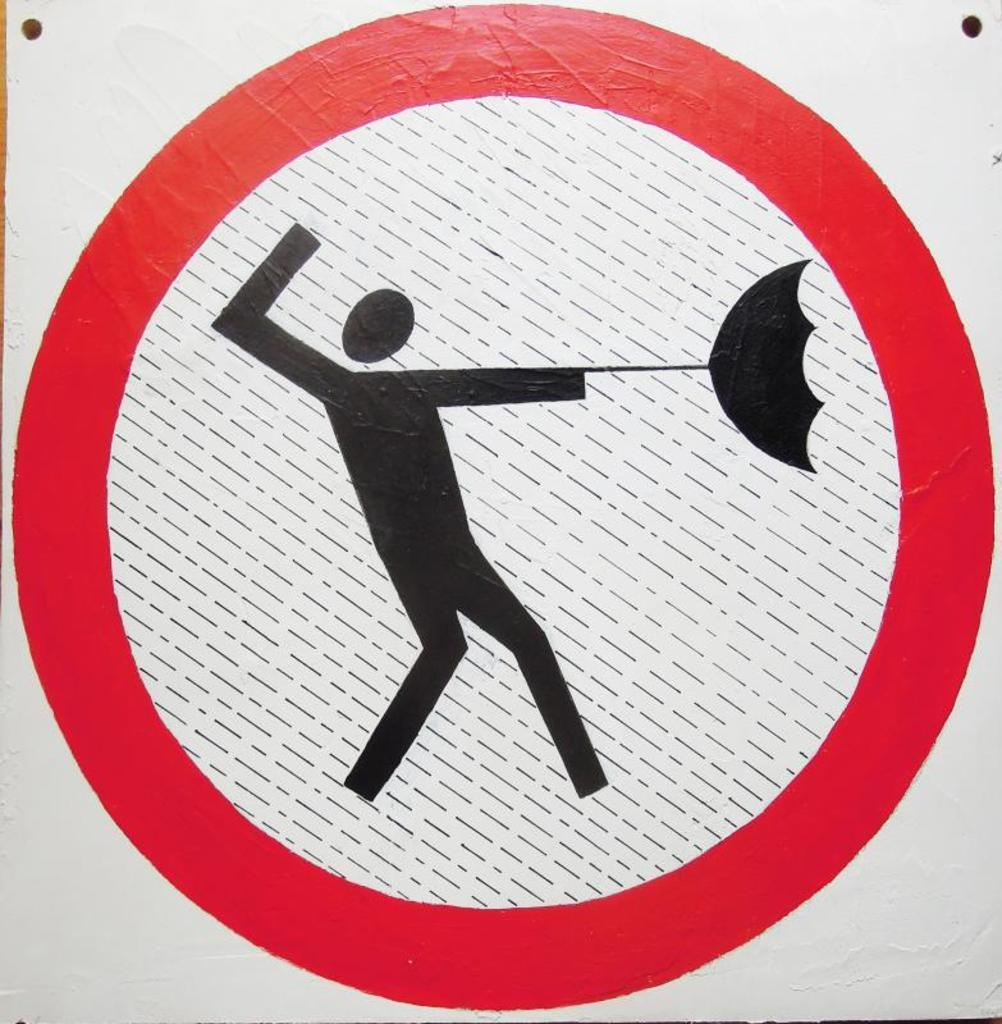What is the main object in the image? There is a sign board in the image. Can you describe the sign board in more detail? Unfortunately, the provided facts do not give any additional details about the sign board. What color is the suit worn by the person standing next to the sign board? There is no person or suit mentioned in the provided facts, so we cannot answer this question. 